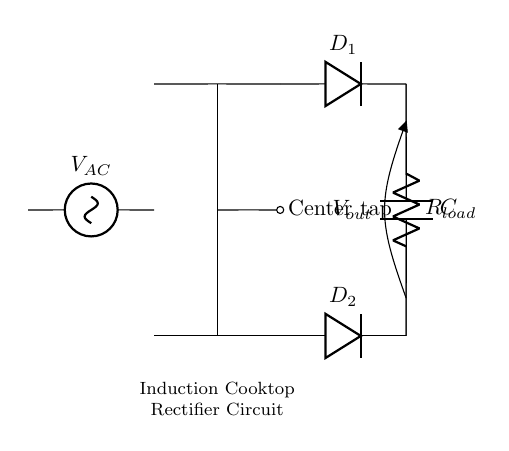What is the function of the center tap in this circuit? The center tap allows the transformer to provide two equal voltages from opposite ends, essentially splitting the input voltage into two halves for rectification.
Answer: Splits voltage What are the two diodes in this circuit? The circuit diagram shows Diode D1 and Diode D2, which are used to convert AC voltage into DC voltage during the rectification process.
Answer: D1 and D2 What component is used to smooth the output voltage? The capacitor is used in the circuit to smooth out the rectified DC voltage by reducing fluctuations, hence maintaining a more stable output.
Answer: Capacitor How many resistors are in this circuit? The circuit contains one resistor, labeled R_load, which represents the load in the circuit that the output voltage is applied to.
Answer: One resistor What happens to the alternating current in this circuit? The alternating current is converted into direct current as it passes through the diodes, which only allow current to flow in one direction.
Answer: Converted to DC What is the load resistance represented as in the circuit? The load resistance is denoted as R_load, representing the component or device using the output power from the circuit.
Answer: R_load What type of circuit is this? This is a center-tapped transformer rectifier circuit, specifically designed for the purpose of converting AC to DC in applications like induction cooktops.
Answer: Rectifier circuit 